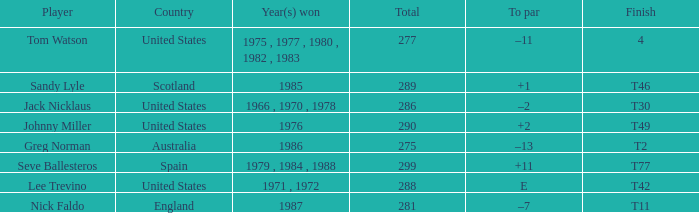What's england's to par? –7. 